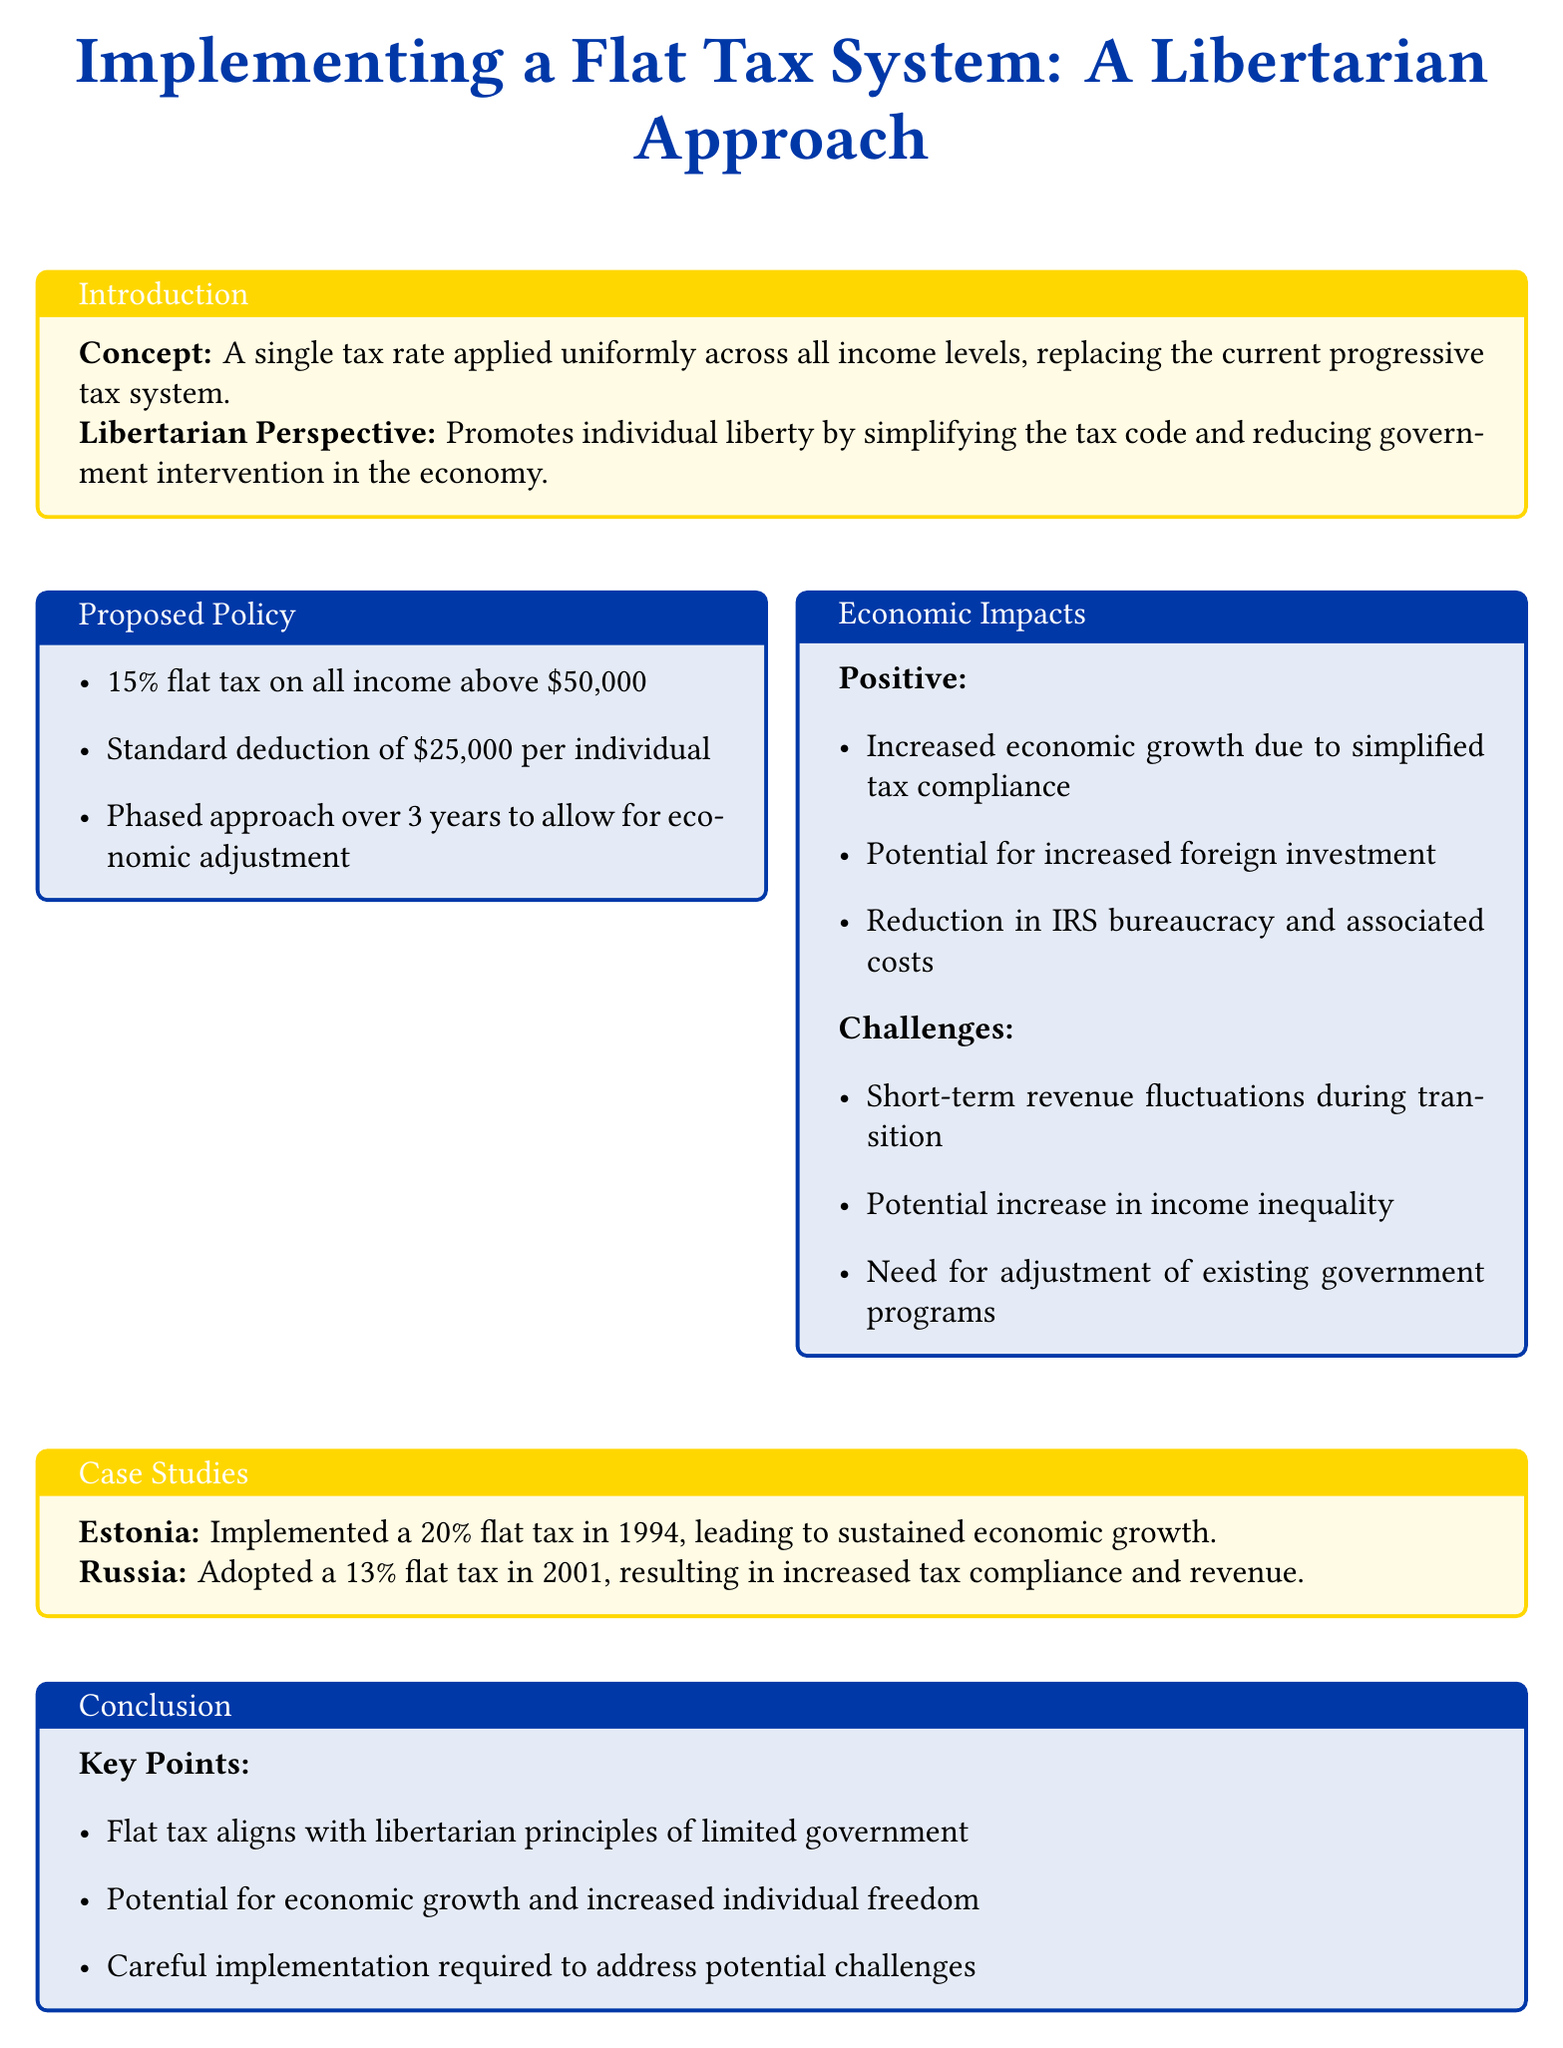What is the proposed flat tax rate? The proposed policy states a flat tax rate of 15% on all income above $50,000.
Answer: 15% What is the standard deduction amount? The document mentions a standard deduction of $25,000 per individual.
Answer: $25,000 In what timeframe is the phased approach planned? The document indicates a phased approach over 3 years to allow for economic adjustment.
Answer: 3 years What is a potential economic impact of the flat tax system? The document lists increased economic growth as a positive impact of the proposed flat tax system.
Answer: Increased economic growth What challenge is mentioned regarding income inequality? The potential for increased income inequality is noted as a challenge in the economic impacts section.
Answer: Increased income inequality Which country adopted a flat tax in 2001? The document states that Russia adopted a 13% flat tax in 2001.
Answer: Russia What principle does the flat tax align with? The document states that the flat tax aligns with libertarian principles of limited government.
Answer: Limited government What was Estonia's flat tax rate implemented in 1994? According to the case studies presented, Estonia implemented a flat tax rate of 20%.
Answer: 20% What is a key recommendation for implementation? The conclusion emphasizes that careful implementation is required to address potential challenges.
Answer: Careful implementation 